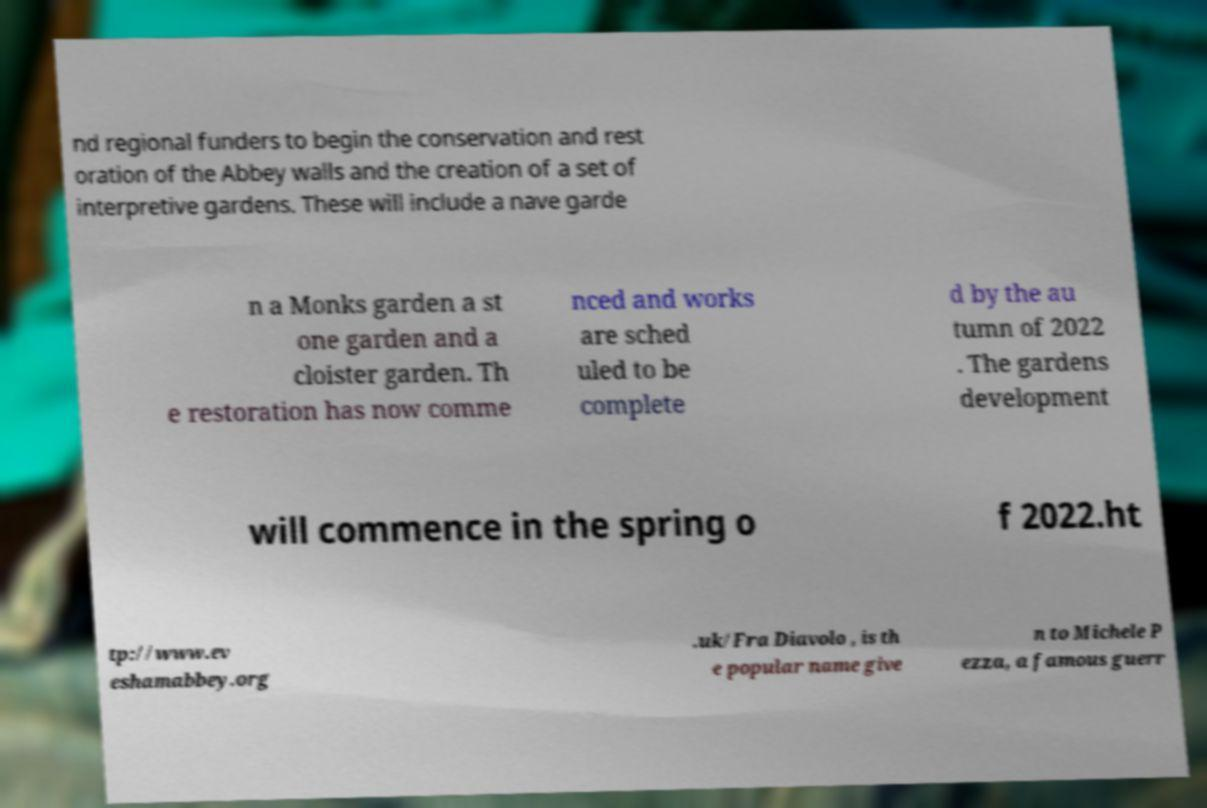There's text embedded in this image that I need extracted. Can you transcribe it verbatim? nd regional funders to begin the conservation and rest oration of the Abbey walls and the creation of a set of interpretive gardens. These will include a nave garde n a Monks garden a st one garden and a cloister garden. Th e restoration has now comme nced and works are sched uled to be complete d by the au tumn of 2022 . The gardens development will commence in the spring o f 2022.ht tp://www.ev eshamabbey.org .uk/Fra Diavolo , is th e popular name give n to Michele P ezza, a famous guerr 